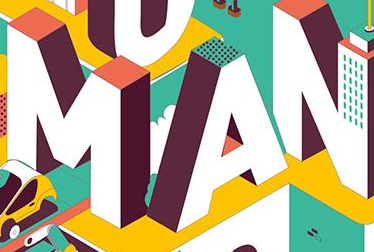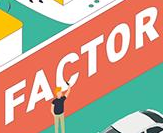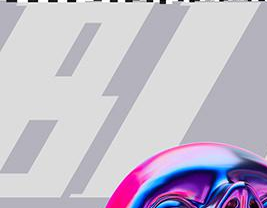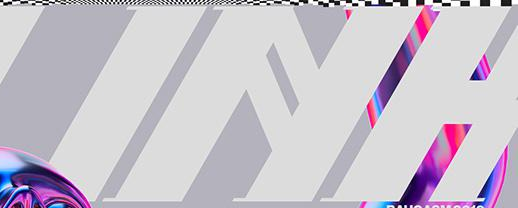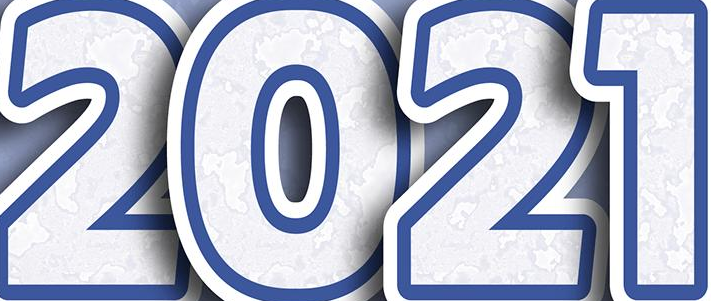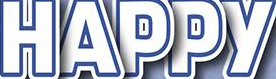What words can you see in these images in sequence, separated by a semicolon? MAN; FACTOR; BI; INH; 2021; HAPPY 